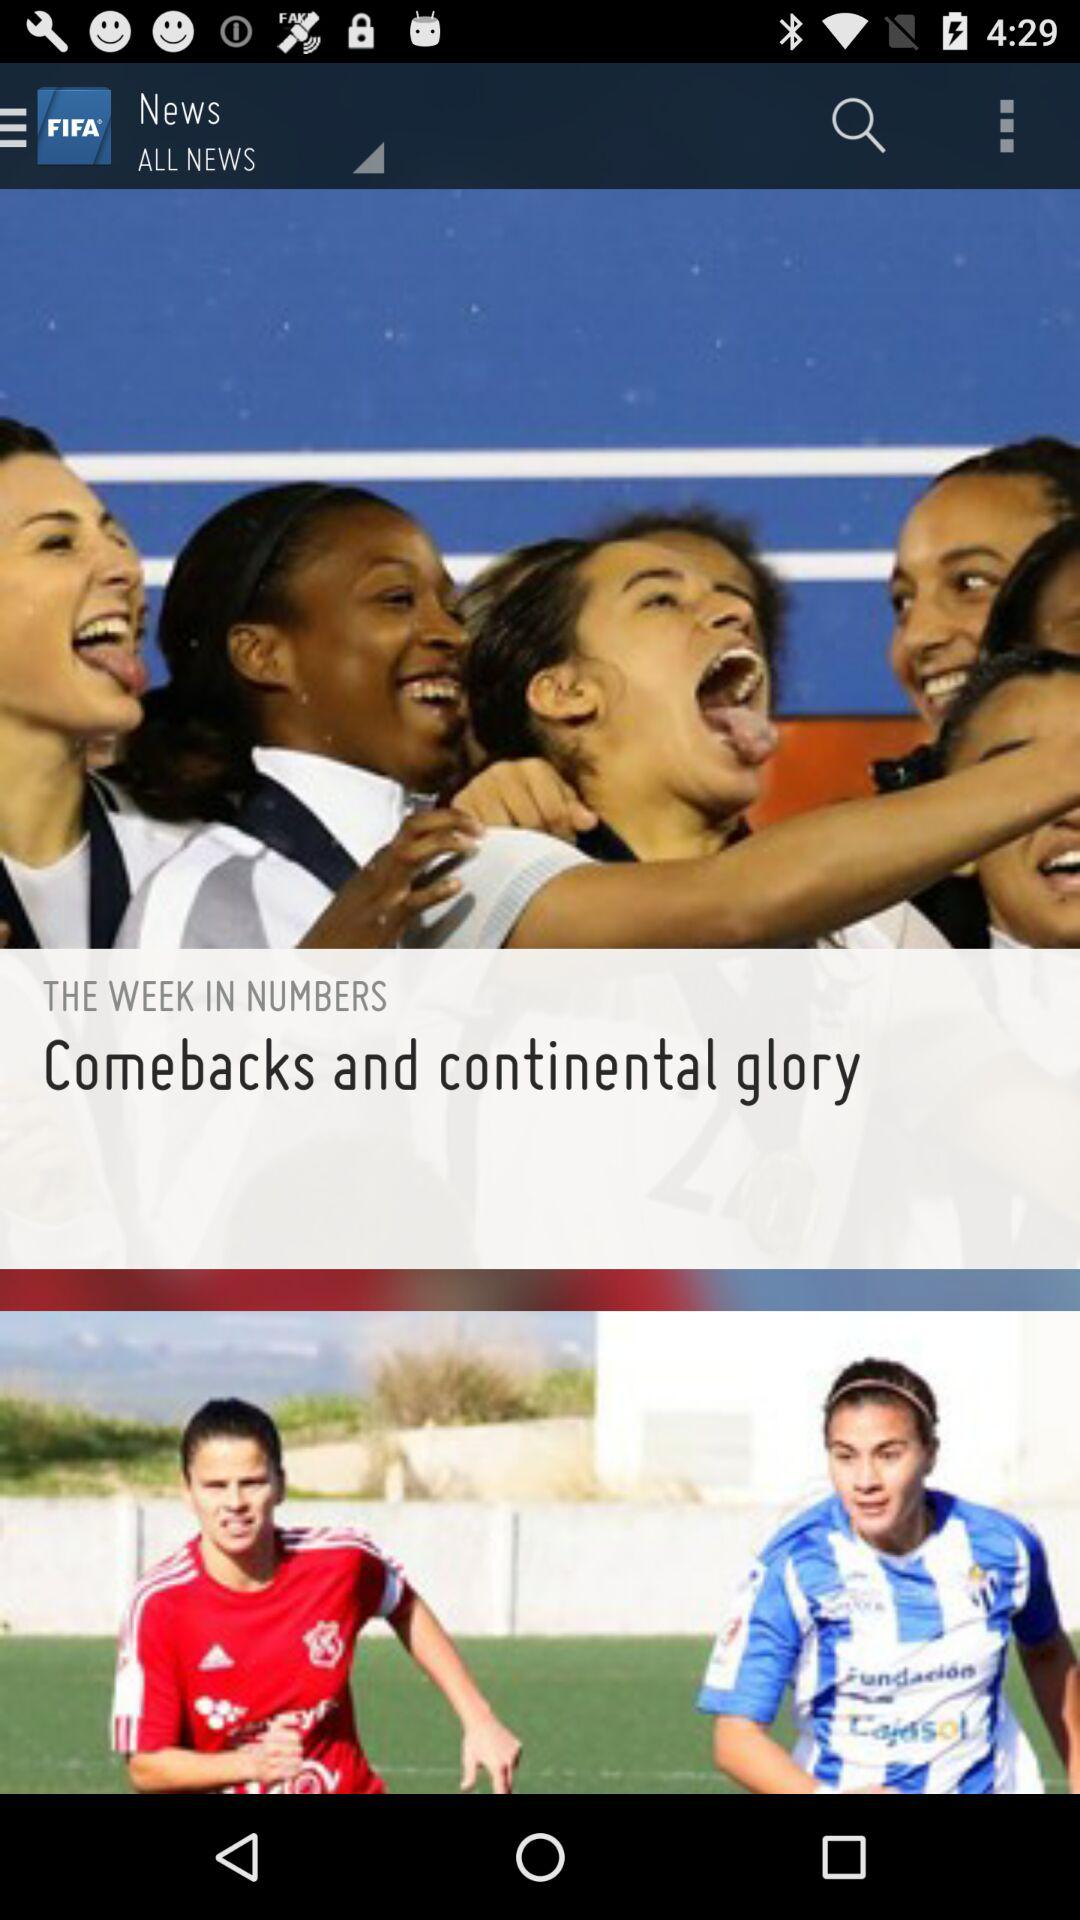When was the news updated?
When the provided information is insufficient, respond with <no answer>. <no answer> 